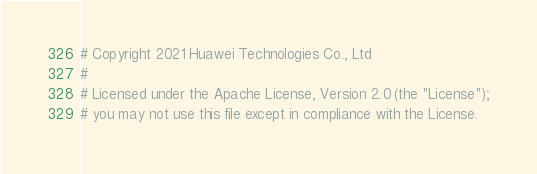<code> <loc_0><loc_0><loc_500><loc_500><_Python_># Copyright 2021 Huawei Technologies Co., Ltd
#
# Licensed under the Apache License, Version 2.0 (the "License");
# you may not use this file except in compliance with the License.</code> 